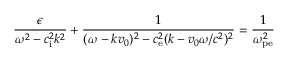Convert formula to latex. <formula><loc_0><loc_0><loc_500><loc_500>\frac { \epsilon } { \omega ^ { 2 } - c _ { i } ^ { 2 } k ^ { 2 } } + \frac { 1 } { ( \omega - k v _ { 0 } ) ^ { 2 } - c _ { e } ^ { 2 } ( k - v _ { 0 } \omega / c ^ { 2 } ) ^ { 2 } } = \frac { 1 } { \omega _ { p e } ^ { 2 } }</formula> 